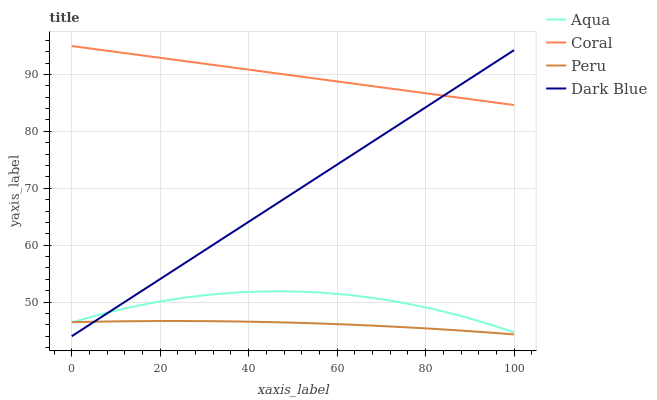Does Peru have the minimum area under the curve?
Answer yes or no. Yes. Does Coral have the maximum area under the curve?
Answer yes or no. Yes. Does Aqua have the minimum area under the curve?
Answer yes or no. No. Does Aqua have the maximum area under the curve?
Answer yes or no. No. Is Coral the smoothest?
Answer yes or no. Yes. Is Aqua the roughest?
Answer yes or no. Yes. Is Aqua the smoothest?
Answer yes or no. No. Is Coral the roughest?
Answer yes or no. No. Does Dark Blue have the lowest value?
Answer yes or no. Yes. Does Aqua have the lowest value?
Answer yes or no. No. Does Coral have the highest value?
Answer yes or no. Yes. Does Aqua have the highest value?
Answer yes or no. No. Is Aqua less than Coral?
Answer yes or no. Yes. Is Coral greater than Aqua?
Answer yes or no. Yes. Does Dark Blue intersect Coral?
Answer yes or no. Yes. Is Dark Blue less than Coral?
Answer yes or no. No. Is Dark Blue greater than Coral?
Answer yes or no. No. Does Aqua intersect Coral?
Answer yes or no. No. 